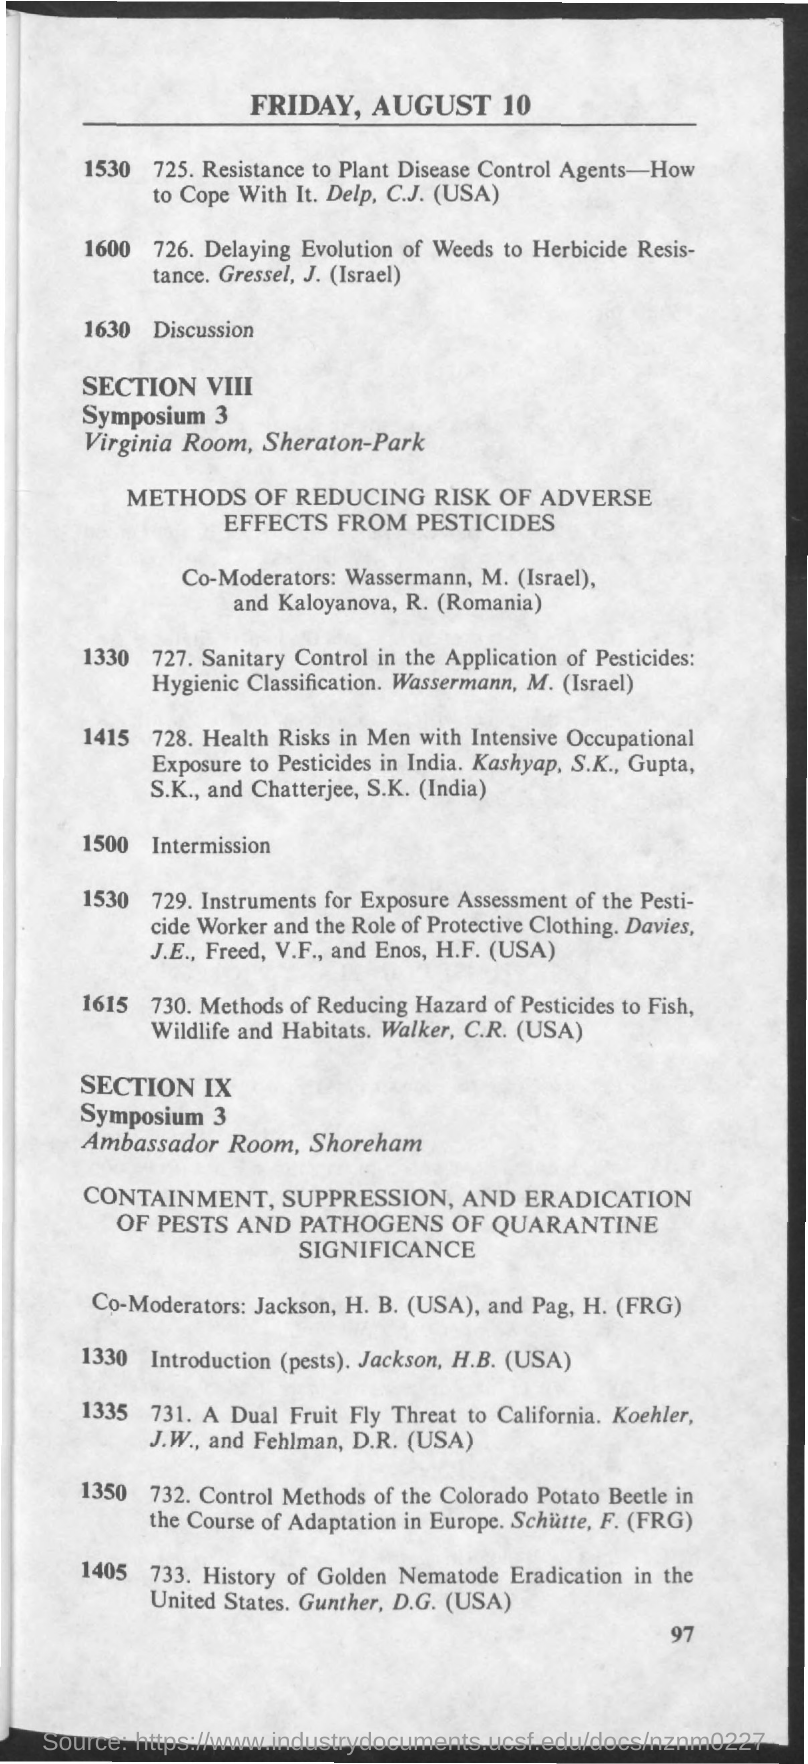What is the Page Number?
Offer a terse response. 97. 